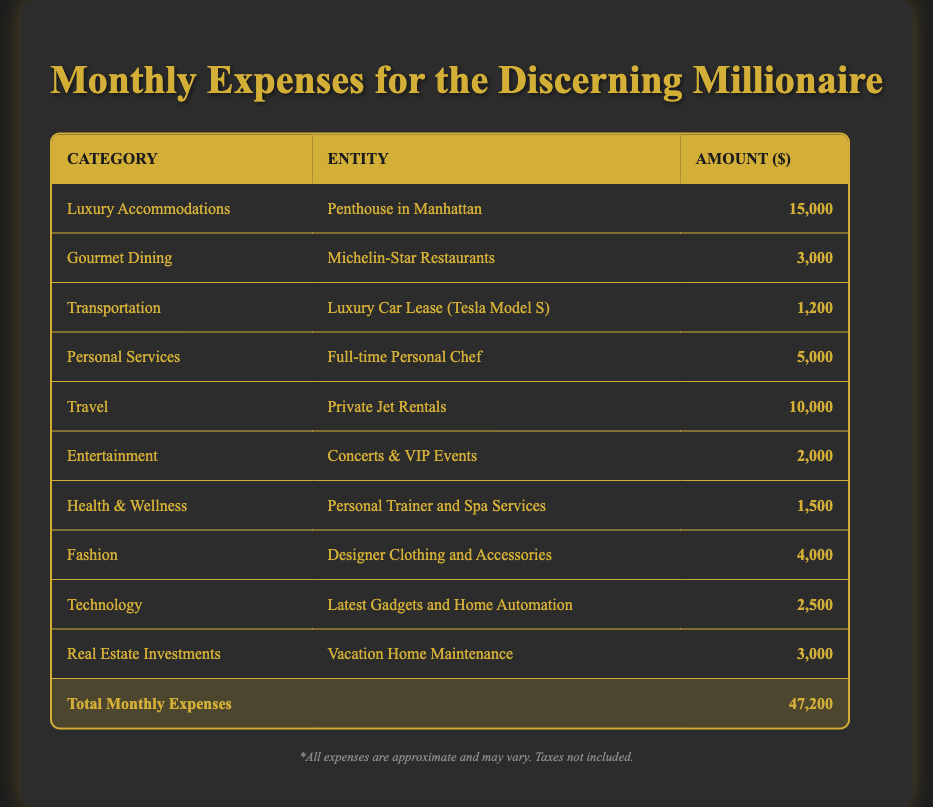What is the total amount spent on luxury accommodations? The table lists one entity under luxury accommodations, which is the penthouse in Manhattan, with an amount of 15,000. Therefore, the total amount spent in this category is simply the amount listed.
Answer: 15,000 How much is spent on gourmet dining and entertainment combined? The amount spent on gourmet dining is 3,000, and the amount spent on entertainment is 2,000. Adding these amounts together gives us 3,000 + 2,000 = 5,000.
Answer: 5,000 Is the total monthly expense greater than 50,000? The total monthly expenses listed in the table is 47,200. Since 47,200 is less than 50,000, the statement is false.
Answer: No What is the average monthly expense across all categories? There are 10 categories of expenses listed. The total amount is 47,200. To find the average, divide the total by the number of categories: 47,200 / 10 = 4,720.
Answer: 4,720 How much more is spent on travel compared to personal services? The amount spent on travel is 10,000 and on personal services is 5,000. The difference is calculated as 10,000 - 5,000 = 5,000.
Answer: 5,000 Is there a category where the monthly expense is equal to or less than 1,500? The table has a category for health and wellness, which is listed at 1,500. This shows that there is a category with an amount equal to or less than 1,500.
Answer: Yes Which category has the highest monthly expense? The highest amount in the table is found under luxury accommodations for the penthouse in Manhattan, listed at 15,000. This is higher than any other category.
Answer: Luxury Accommodations What percentage of the total expenses is spent on fashion? The amount spent on fashion is 4,000. To find the percentage of total expenses (47,200), divide by the total and multiply by 100: (4,000 / 47,200) * 100 = 8.47%.
Answer: 8.47% How do the expenses for technology and transportation compare? The amount for technology is 2,500 and for transportation is 1,200. Since 2,500 is greater, we see that technology expenses are higher than those for transportation.
Answer: Technology is higher 